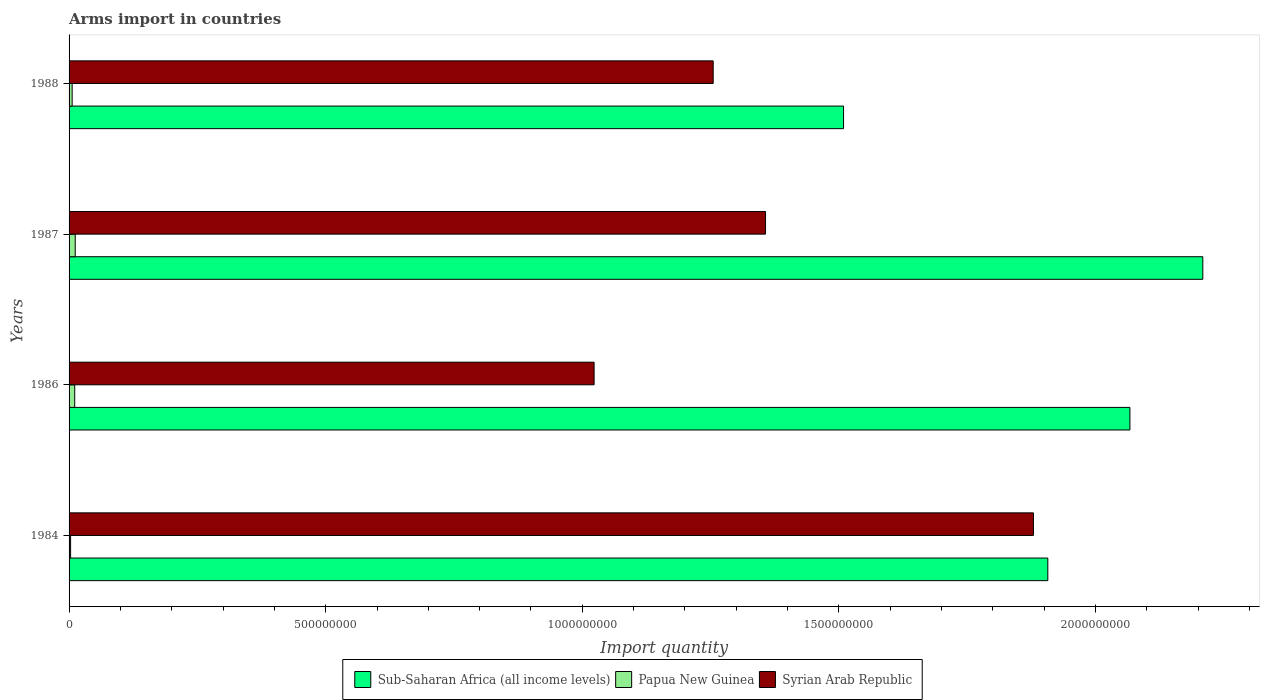How many different coloured bars are there?
Your response must be concise. 3. How many groups of bars are there?
Provide a short and direct response. 4. Are the number of bars per tick equal to the number of legend labels?
Make the answer very short. Yes. How many bars are there on the 3rd tick from the top?
Your response must be concise. 3. How many bars are there on the 4th tick from the bottom?
Provide a succinct answer. 3. What is the label of the 2nd group of bars from the top?
Your answer should be compact. 1987. What is the total arms import in Papua New Guinea in 1984?
Offer a very short reply. 3.00e+06. Across all years, what is the maximum total arms import in Syrian Arab Republic?
Your answer should be very brief. 1.88e+09. In which year was the total arms import in Sub-Saharan Africa (all income levels) maximum?
Give a very brief answer. 1987. What is the total total arms import in Syrian Arab Republic in the graph?
Provide a short and direct response. 5.51e+09. What is the difference between the total arms import in Sub-Saharan Africa (all income levels) in 1987 and that in 1988?
Ensure brevity in your answer.  7.00e+08. What is the difference between the total arms import in Syrian Arab Republic in 1987 and the total arms import in Papua New Guinea in 1988?
Provide a short and direct response. 1.35e+09. What is the average total arms import in Syrian Arab Republic per year?
Provide a succinct answer. 1.38e+09. In the year 1987, what is the difference between the total arms import in Syrian Arab Republic and total arms import in Papua New Guinea?
Keep it short and to the point. 1.34e+09. What is the ratio of the total arms import in Sub-Saharan Africa (all income levels) in 1984 to that in 1988?
Your answer should be compact. 1.26. What is the difference between the highest and the second highest total arms import in Sub-Saharan Africa (all income levels)?
Ensure brevity in your answer.  1.42e+08. What is the difference between the highest and the lowest total arms import in Syrian Arab Republic?
Provide a short and direct response. 8.56e+08. In how many years, is the total arms import in Syrian Arab Republic greater than the average total arms import in Syrian Arab Republic taken over all years?
Offer a very short reply. 1. Is the sum of the total arms import in Sub-Saharan Africa (all income levels) in 1984 and 1987 greater than the maximum total arms import in Papua New Guinea across all years?
Give a very brief answer. Yes. What does the 3rd bar from the top in 1987 represents?
Ensure brevity in your answer.  Sub-Saharan Africa (all income levels). What does the 3rd bar from the bottom in 1987 represents?
Your answer should be compact. Syrian Arab Republic. How many bars are there?
Ensure brevity in your answer.  12. Does the graph contain any zero values?
Your answer should be very brief. No. Does the graph contain grids?
Ensure brevity in your answer.  No. Where does the legend appear in the graph?
Give a very brief answer. Bottom center. How are the legend labels stacked?
Ensure brevity in your answer.  Horizontal. What is the title of the graph?
Offer a terse response. Arms import in countries. What is the label or title of the X-axis?
Keep it short and to the point. Import quantity. What is the Import quantity in Sub-Saharan Africa (all income levels) in 1984?
Ensure brevity in your answer.  1.91e+09. What is the Import quantity of Syrian Arab Republic in 1984?
Your answer should be very brief. 1.88e+09. What is the Import quantity of Sub-Saharan Africa (all income levels) in 1986?
Give a very brief answer. 2.07e+09. What is the Import quantity of Papua New Guinea in 1986?
Offer a very short reply. 1.10e+07. What is the Import quantity of Syrian Arab Republic in 1986?
Your answer should be very brief. 1.02e+09. What is the Import quantity in Sub-Saharan Africa (all income levels) in 1987?
Provide a short and direct response. 2.21e+09. What is the Import quantity of Papua New Guinea in 1987?
Your answer should be compact. 1.20e+07. What is the Import quantity in Syrian Arab Republic in 1987?
Make the answer very short. 1.36e+09. What is the Import quantity of Sub-Saharan Africa (all income levels) in 1988?
Keep it short and to the point. 1.51e+09. What is the Import quantity of Papua New Guinea in 1988?
Provide a succinct answer. 6.00e+06. What is the Import quantity in Syrian Arab Republic in 1988?
Offer a very short reply. 1.26e+09. Across all years, what is the maximum Import quantity of Sub-Saharan Africa (all income levels)?
Give a very brief answer. 2.21e+09. Across all years, what is the maximum Import quantity of Syrian Arab Republic?
Give a very brief answer. 1.88e+09. Across all years, what is the minimum Import quantity of Sub-Saharan Africa (all income levels)?
Give a very brief answer. 1.51e+09. Across all years, what is the minimum Import quantity of Syrian Arab Republic?
Ensure brevity in your answer.  1.02e+09. What is the total Import quantity of Sub-Saharan Africa (all income levels) in the graph?
Your answer should be compact. 7.69e+09. What is the total Import quantity of Papua New Guinea in the graph?
Offer a terse response. 3.20e+07. What is the total Import quantity of Syrian Arab Republic in the graph?
Your answer should be very brief. 5.51e+09. What is the difference between the Import quantity in Sub-Saharan Africa (all income levels) in 1984 and that in 1986?
Provide a succinct answer. -1.60e+08. What is the difference between the Import quantity in Papua New Guinea in 1984 and that in 1986?
Your response must be concise. -8.00e+06. What is the difference between the Import quantity of Syrian Arab Republic in 1984 and that in 1986?
Your response must be concise. 8.56e+08. What is the difference between the Import quantity in Sub-Saharan Africa (all income levels) in 1984 and that in 1987?
Offer a terse response. -3.02e+08. What is the difference between the Import quantity in Papua New Guinea in 1984 and that in 1987?
Offer a very short reply. -9.00e+06. What is the difference between the Import quantity of Syrian Arab Republic in 1984 and that in 1987?
Provide a succinct answer. 5.22e+08. What is the difference between the Import quantity of Sub-Saharan Africa (all income levels) in 1984 and that in 1988?
Keep it short and to the point. 3.98e+08. What is the difference between the Import quantity of Syrian Arab Republic in 1984 and that in 1988?
Offer a very short reply. 6.24e+08. What is the difference between the Import quantity in Sub-Saharan Africa (all income levels) in 1986 and that in 1987?
Your response must be concise. -1.42e+08. What is the difference between the Import quantity of Papua New Guinea in 1986 and that in 1987?
Keep it short and to the point. -1.00e+06. What is the difference between the Import quantity of Syrian Arab Republic in 1986 and that in 1987?
Keep it short and to the point. -3.34e+08. What is the difference between the Import quantity in Sub-Saharan Africa (all income levels) in 1986 and that in 1988?
Make the answer very short. 5.58e+08. What is the difference between the Import quantity in Papua New Guinea in 1986 and that in 1988?
Provide a short and direct response. 5.00e+06. What is the difference between the Import quantity in Syrian Arab Republic in 1986 and that in 1988?
Your response must be concise. -2.32e+08. What is the difference between the Import quantity of Sub-Saharan Africa (all income levels) in 1987 and that in 1988?
Offer a very short reply. 7.00e+08. What is the difference between the Import quantity in Syrian Arab Republic in 1987 and that in 1988?
Offer a very short reply. 1.02e+08. What is the difference between the Import quantity in Sub-Saharan Africa (all income levels) in 1984 and the Import quantity in Papua New Guinea in 1986?
Offer a very short reply. 1.90e+09. What is the difference between the Import quantity in Sub-Saharan Africa (all income levels) in 1984 and the Import quantity in Syrian Arab Republic in 1986?
Offer a very short reply. 8.84e+08. What is the difference between the Import quantity in Papua New Guinea in 1984 and the Import quantity in Syrian Arab Republic in 1986?
Keep it short and to the point. -1.02e+09. What is the difference between the Import quantity in Sub-Saharan Africa (all income levels) in 1984 and the Import quantity in Papua New Guinea in 1987?
Give a very brief answer. 1.90e+09. What is the difference between the Import quantity in Sub-Saharan Africa (all income levels) in 1984 and the Import quantity in Syrian Arab Republic in 1987?
Your answer should be very brief. 5.50e+08. What is the difference between the Import quantity of Papua New Guinea in 1984 and the Import quantity of Syrian Arab Republic in 1987?
Offer a terse response. -1.35e+09. What is the difference between the Import quantity of Sub-Saharan Africa (all income levels) in 1984 and the Import quantity of Papua New Guinea in 1988?
Ensure brevity in your answer.  1.90e+09. What is the difference between the Import quantity of Sub-Saharan Africa (all income levels) in 1984 and the Import quantity of Syrian Arab Republic in 1988?
Your response must be concise. 6.52e+08. What is the difference between the Import quantity in Papua New Guinea in 1984 and the Import quantity in Syrian Arab Republic in 1988?
Provide a short and direct response. -1.25e+09. What is the difference between the Import quantity of Sub-Saharan Africa (all income levels) in 1986 and the Import quantity of Papua New Guinea in 1987?
Your answer should be very brief. 2.06e+09. What is the difference between the Import quantity of Sub-Saharan Africa (all income levels) in 1986 and the Import quantity of Syrian Arab Republic in 1987?
Offer a terse response. 7.10e+08. What is the difference between the Import quantity in Papua New Guinea in 1986 and the Import quantity in Syrian Arab Republic in 1987?
Provide a short and direct response. -1.35e+09. What is the difference between the Import quantity in Sub-Saharan Africa (all income levels) in 1986 and the Import quantity in Papua New Guinea in 1988?
Offer a very short reply. 2.06e+09. What is the difference between the Import quantity in Sub-Saharan Africa (all income levels) in 1986 and the Import quantity in Syrian Arab Republic in 1988?
Keep it short and to the point. 8.12e+08. What is the difference between the Import quantity in Papua New Guinea in 1986 and the Import quantity in Syrian Arab Republic in 1988?
Offer a terse response. -1.24e+09. What is the difference between the Import quantity of Sub-Saharan Africa (all income levels) in 1987 and the Import quantity of Papua New Guinea in 1988?
Make the answer very short. 2.20e+09. What is the difference between the Import quantity in Sub-Saharan Africa (all income levels) in 1987 and the Import quantity in Syrian Arab Republic in 1988?
Make the answer very short. 9.54e+08. What is the difference between the Import quantity in Papua New Guinea in 1987 and the Import quantity in Syrian Arab Republic in 1988?
Your answer should be very brief. -1.24e+09. What is the average Import quantity of Sub-Saharan Africa (all income levels) per year?
Offer a terse response. 1.92e+09. What is the average Import quantity of Syrian Arab Republic per year?
Give a very brief answer. 1.38e+09. In the year 1984, what is the difference between the Import quantity in Sub-Saharan Africa (all income levels) and Import quantity in Papua New Guinea?
Ensure brevity in your answer.  1.90e+09. In the year 1984, what is the difference between the Import quantity of Sub-Saharan Africa (all income levels) and Import quantity of Syrian Arab Republic?
Ensure brevity in your answer.  2.80e+07. In the year 1984, what is the difference between the Import quantity in Papua New Guinea and Import quantity in Syrian Arab Republic?
Make the answer very short. -1.88e+09. In the year 1986, what is the difference between the Import quantity in Sub-Saharan Africa (all income levels) and Import quantity in Papua New Guinea?
Your answer should be compact. 2.06e+09. In the year 1986, what is the difference between the Import quantity in Sub-Saharan Africa (all income levels) and Import quantity in Syrian Arab Republic?
Your response must be concise. 1.04e+09. In the year 1986, what is the difference between the Import quantity in Papua New Guinea and Import quantity in Syrian Arab Republic?
Keep it short and to the point. -1.01e+09. In the year 1987, what is the difference between the Import quantity of Sub-Saharan Africa (all income levels) and Import quantity of Papua New Guinea?
Make the answer very short. 2.20e+09. In the year 1987, what is the difference between the Import quantity of Sub-Saharan Africa (all income levels) and Import quantity of Syrian Arab Republic?
Ensure brevity in your answer.  8.52e+08. In the year 1987, what is the difference between the Import quantity in Papua New Guinea and Import quantity in Syrian Arab Republic?
Provide a short and direct response. -1.34e+09. In the year 1988, what is the difference between the Import quantity in Sub-Saharan Africa (all income levels) and Import quantity in Papua New Guinea?
Your answer should be very brief. 1.50e+09. In the year 1988, what is the difference between the Import quantity of Sub-Saharan Africa (all income levels) and Import quantity of Syrian Arab Republic?
Your answer should be very brief. 2.54e+08. In the year 1988, what is the difference between the Import quantity in Papua New Guinea and Import quantity in Syrian Arab Republic?
Keep it short and to the point. -1.25e+09. What is the ratio of the Import quantity of Sub-Saharan Africa (all income levels) in 1984 to that in 1986?
Your response must be concise. 0.92. What is the ratio of the Import quantity of Papua New Guinea in 1984 to that in 1986?
Your answer should be very brief. 0.27. What is the ratio of the Import quantity in Syrian Arab Republic in 1984 to that in 1986?
Provide a short and direct response. 1.84. What is the ratio of the Import quantity of Sub-Saharan Africa (all income levels) in 1984 to that in 1987?
Ensure brevity in your answer.  0.86. What is the ratio of the Import quantity in Syrian Arab Republic in 1984 to that in 1987?
Provide a succinct answer. 1.38. What is the ratio of the Import quantity in Sub-Saharan Africa (all income levels) in 1984 to that in 1988?
Your response must be concise. 1.26. What is the ratio of the Import quantity of Syrian Arab Republic in 1984 to that in 1988?
Your answer should be very brief. 1.5. What is the ratio of the Import quantity of Sub-Saharan Africa (all income levels) in 1986 to that in 1987?
Provide a short and direct response. 0.94. What is the ratio of the Import quantity of Syrian Arab Republic in 1986 to that in 1987?
Offer a very short reply. 0.75. What is the ratio of the Import quantity of Sub-Saharan Africa (all income levels) in 1986 to that in 1988?
Your answer should be compact. 1.37. What is the ratio of the Import quantity in Papua New Guinea in 1986 to that in 1988?
Keep it short and to the point. 1.83. What is the ratio of the Import quantity in Syrian Arab Republic in 1986 to that in 1988?
Offer a very short reply. 0.82. What is the ratio of the Import quantity in Sub-Saharan Africa (all income levels) in 1987 to that in 1988?
Your answer should be very brief. 1.46. What is the ratio of the Import quantity in Syrian Arab Republic in 1987 to that in 1988?
Your answer should be very brief. 1.08. What is the difference between the highest and the second highest Import quantity of Sub-Saharan Africa (all income levels)?
Provide a succinct answer. 1.42e+08. What is the difference between the highest and the second highest Import quantity of Papua New Guinea?
Ensure brevity in your answer.  1.00e+06. What is the difference between the highest and the second highest Import quantity in Syrian Arab Republic?
Provide a succinct answer. 5.22e+08. What is the difference between the highest and the lowest Import quantity in Sub-Saharan Africa (all income levels)?
Provide a short and direct response. 7.00e+08. What is the difference between the highest and the lowest Import quantity in Papua New Guinea?
Provide a succinct answer. 9.00e+06. What is the difference between the highest and the lowest Import quantity in Syrian Arab Republic?
Give a very brief answer. 8.56e+08. 